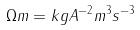Convert formula to latex. <formula><loc_0><loc_0><loc_500><loc_500>\Omega m = k g A ^ { - 2 } m ^ { 3 } s ^ { - 3 }</formula> 